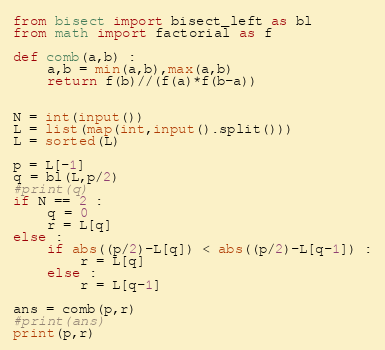Convert code to text. <code><loc_0><loc_0><loc_500><loc_500><_Python_>from bisect import bisect_left as bl
from math import factorial as f

def comb(a,b) :
    a,b = min(a,b),max(a,b)
    return f(b)//(f(a)*f(b-a))


N = int(input())
L = list(map(int,input().split()))
L = sorted(L)

p = L[-1]
q = bl(L,p/2)
#print(q)
if N == 2 :
    q = 0
    r = L[q]
else :
    if abs((p/2)-L[q]) < abs((p/2)-L[q-1]) :
        r = L[q]
    else :
        r = L[q-1]

ans = comb(p,r)
#print(ans)
print(p,r)
</code> 